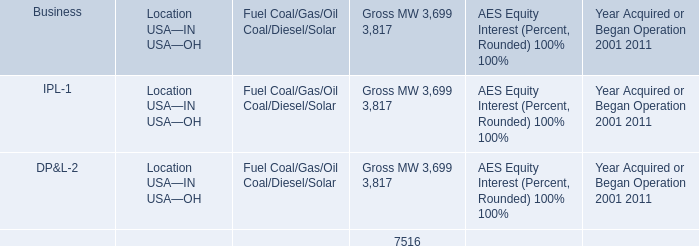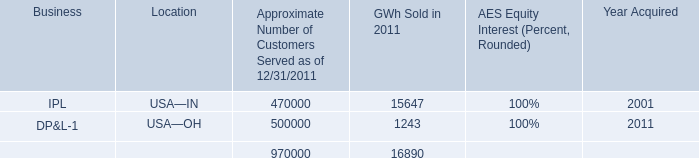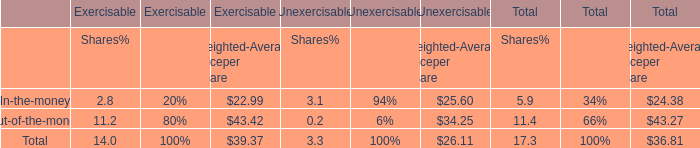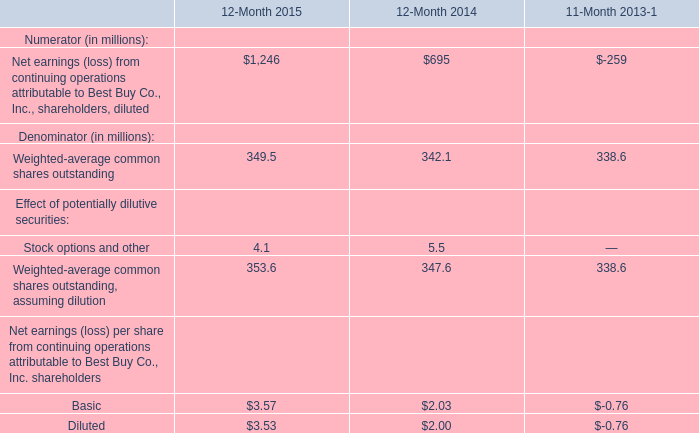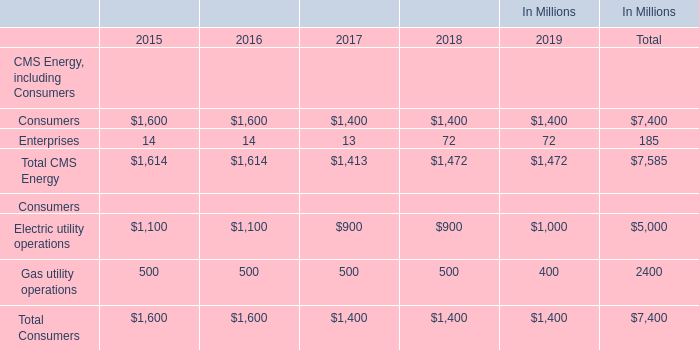Which year the Total CMS Energy is the lowest? 
Answer: 2017. 